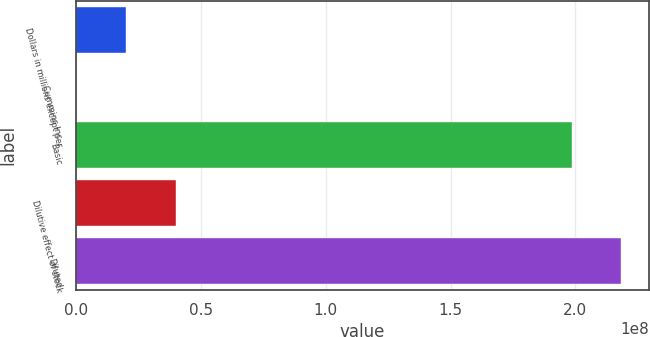Convert chart. <chart><loc_0><loc_0><loc_500><loc_500><bar_chart><fcel>Dollars in millions except per<fcel>Cummins Inc<fcel>Basic<fcel>Dilutive effect of stock<fcel>Diluted<nl><fcel>1.99904e+07<fcel>739<fcel>1.98444e+08<fcel>3.99801e+07<fcel>2.18433e+08<nl></chart> 